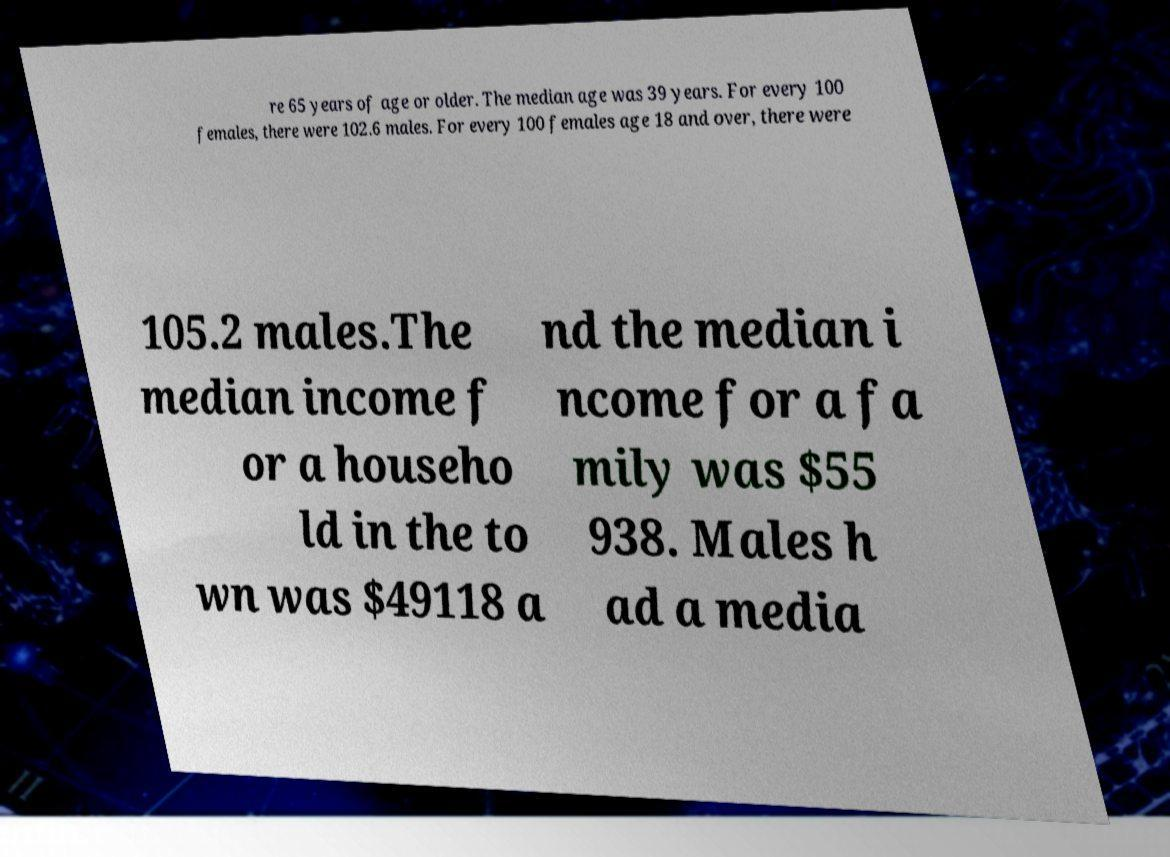For documentation purposes, I need the text within this image transcribed. Could you provide that? re 65 years of age or older. The median age was 39 years. For every 100 females, there were 102.6 males. For every 100 females age 18 and over, there were 105.2 males.The median income f or a househo ld in the to wn was $49118 a nd the median i ncome for a fa mily was $55 938. Males h ad a media 